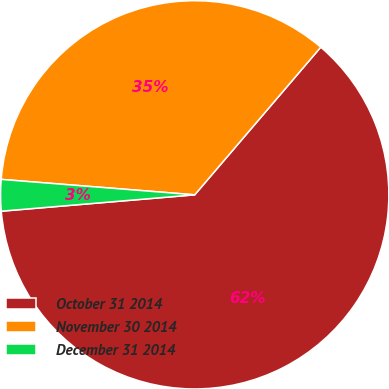<chart> <loc_0><loc_0><loc_500><loc_500><pie_chart><fcel>October 31 2014<fcel>November 30 2014<fcel>December 31 2014<nl><fcel>62.41%<fcel>34.98%<fcel>2.61%<nl></chart> 